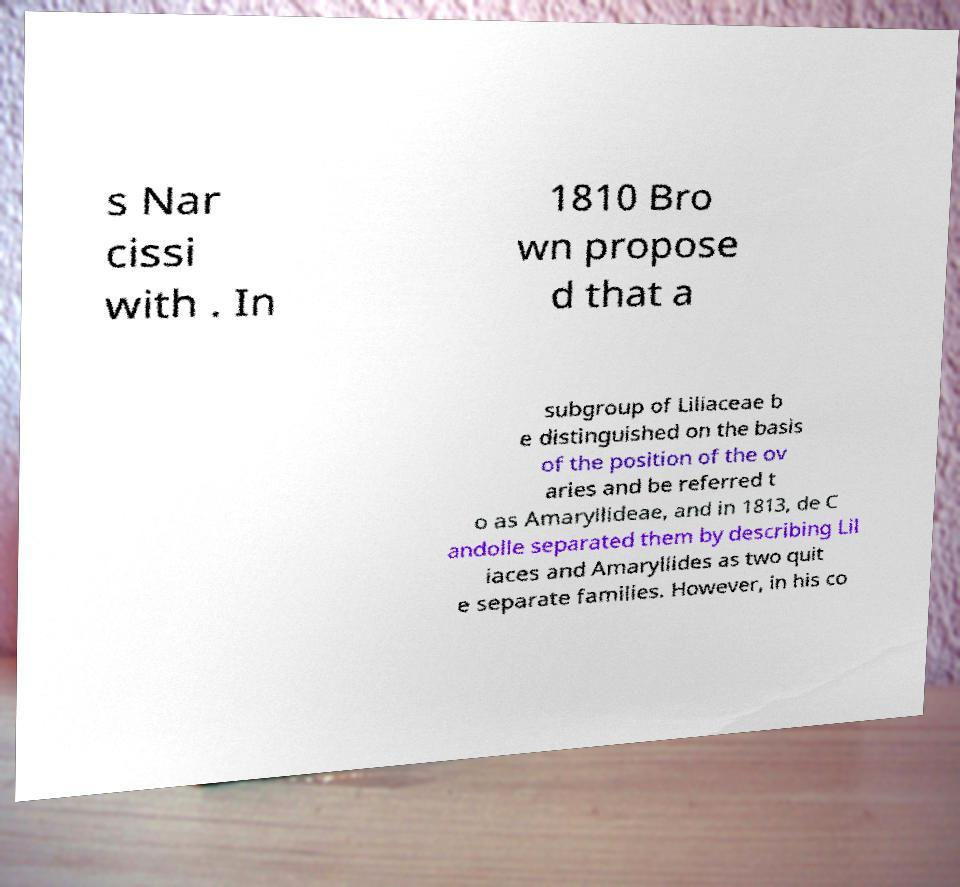Can you read and provide the text displayed in the image?This photo seems to have some interesting text. Can you extract and type it out for me? s Nar cissi with . In 1810 Bro wn propose d that a subgroup of Liliaceae b e distinguished on the basis of the position of the ov aries and be referred t o as Amaryllideae, and in 1813, de C andolle separated them by describing Lil iaces and Amaryllides as two quit e separate families. However, in his co 